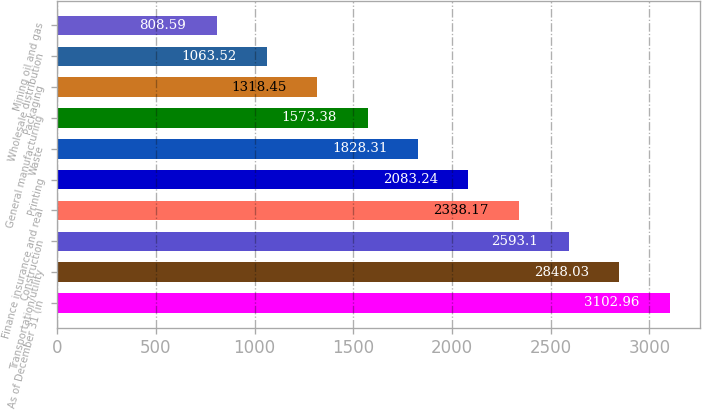Convert chart to OTSL. <chart><loc_0><loc_0><loc_500><loc_500><bar_chart><fcel>As of December 31 (in<fcel>Transportation/utility<fcel>Construction<fcel>Finance insurance and real<fcel>Printing<fcel>Waste<fcel>General manufacturing<fcel>Packaging<fcel>Wholesale distribution<fcel>Mining oil and gas<nl><fcel>3102.96<fcel>2848.03<fcel>2593.1<fcel>2338.17<fcel>2083.24<fcel>1828.31<fcel>1573.38<fcel>1318.45<fcel>1063.52<fcel>808.59<nl></chart> 